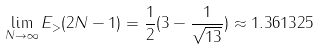Convert formula to latex. <formula><loc_0><loc_0><loc_500><loc_500>\lim _ { N \to \infty } E _ { > } ( 2 N - 1 ) = \frac { 1 } { 2 } ( 3 - \frac { 1 } { \sqrt { 1 3 } } ) \approx 1 . 3 6 1 3 2 5</formula> 